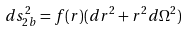Convert formula to latex. <formula><loc_0><loc_0><loc_500><loc_500>d s ^ { 2 } _ { 2 b } = f ( r ) ( d r ^ { 2 } + r ^ { 2 } d \Omega ^ { 2 } )</formula> 